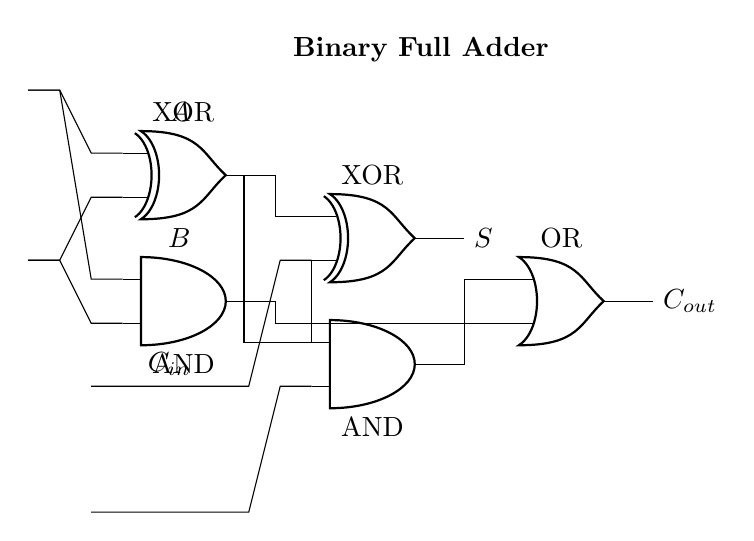What are the inputs to the circuit? The circuit has three inputs labeled A, B, and C in, which signify the two operands and the carry-in for the binary adder.
Answer: A, B, C in How many gates are present in the circuit? The circuit contains four gates: two XOR gates, two AND gates, and one OR gate, which work together to perform the addition.
Answer: Five What is the output of the circuit? The circuit has two outputs labeled S (sum) and C out (carry out) representing the result of the addition operation.
Answer: S, C out What are the types of gates used in this circuit? The gates used in the circuit are XOR for calculating the sum and AND for determining the carry; these gates are employed in a structured manner to implement the binary addition.
Answer: XOR, AND What is the carry-out condition in the circuit? The carry-out occurs when both inputs of the last AND gate feed into it, leading to a positive indication of a carry, typically when the sum exceeds the maximum representable value for a single bit.
Answer: Both inputs high Explain how the output sum S is calculated. The output sum S is calculated by the first XOR gate, which takes inputs A and B, producing an intermediate result. The second XOR gate then combines this result with C in to give the final sum S.
Answer: A XOR B XOR C in 